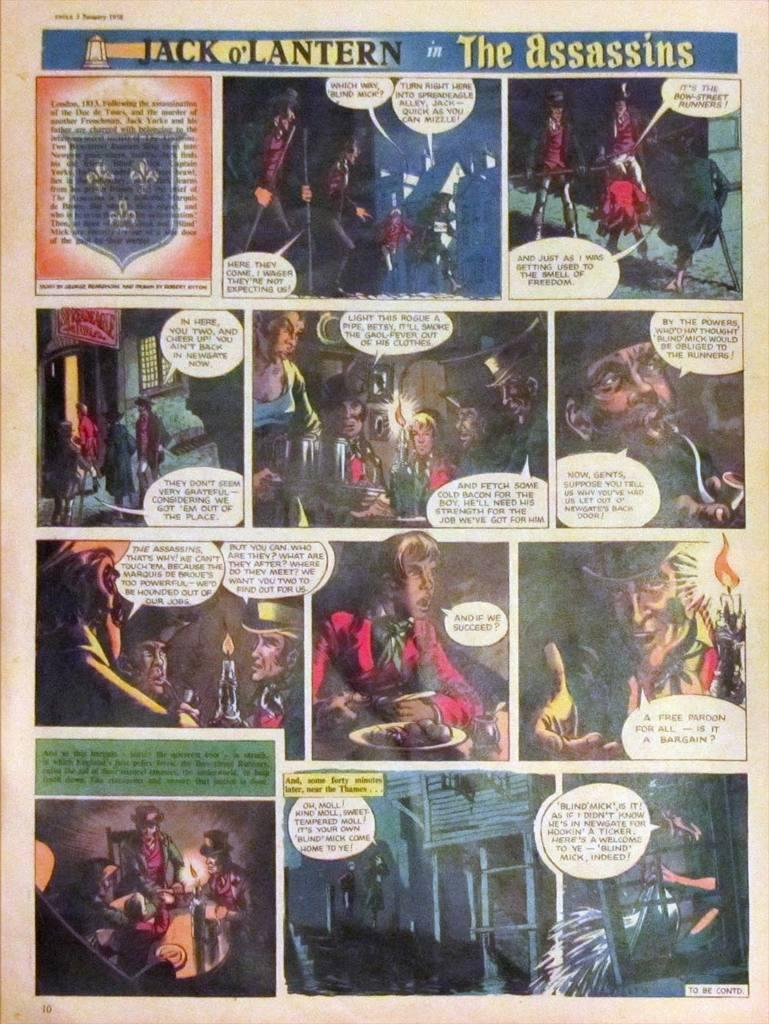<image>
Relay a brief, clear account of the picture shown. The comic was titled, "Jack o' Lantern in the Assassins." 